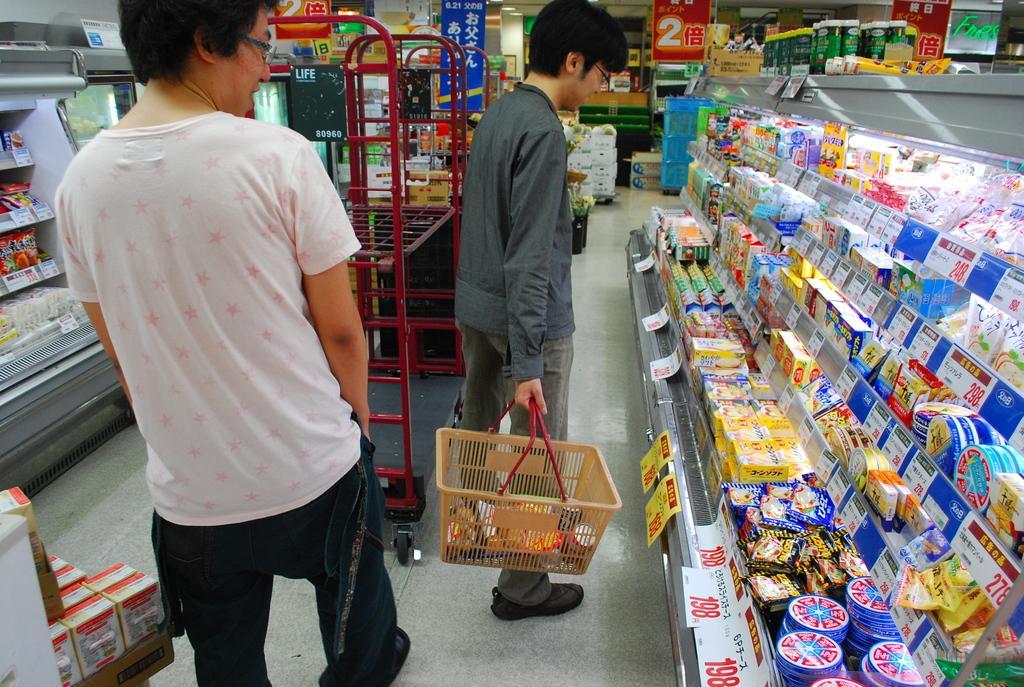Describe this image in one or two sentences. In this picture we can see two men wore spectacles and a man holding a basket with his hand and in front of him we can see packets, boxes in racks with price tags and in the background we can see posters, boxes and some objects. 